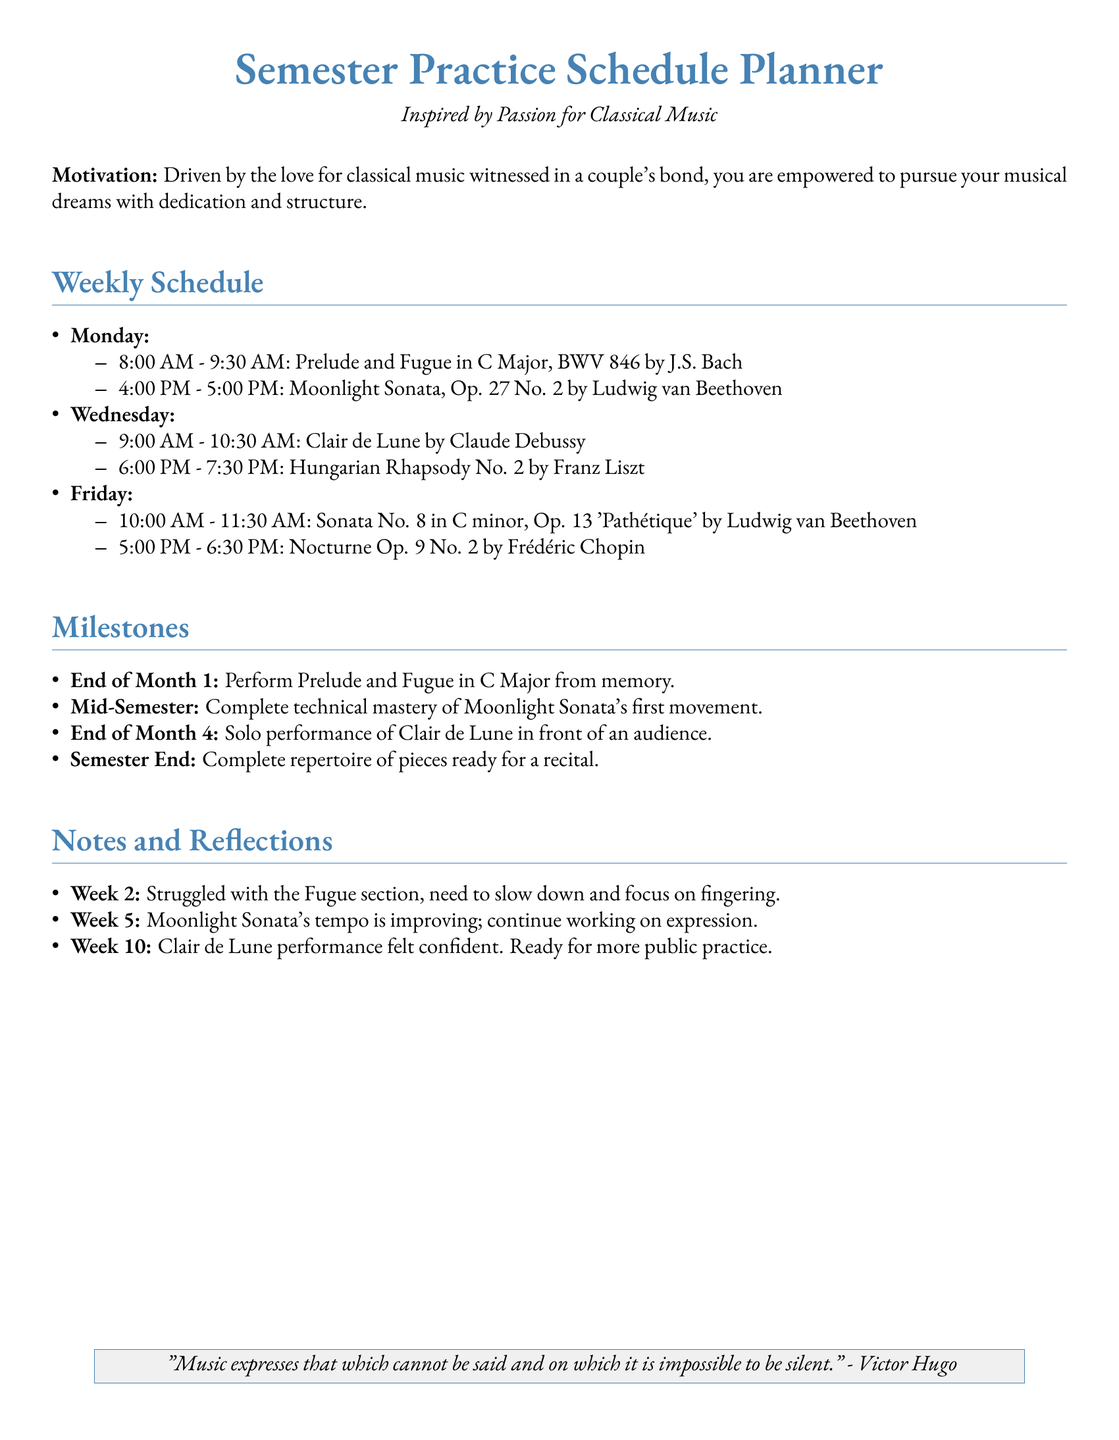what is the title of the document? The title of the document is presented prominently at the beginning, indicating its purpose.
Answer: Semester Practice Schedule Planner who composed the Prelude and Fugue in C Major? This piece is attributed to a well-known composer, highlighted in the schedule.
Answer: J.S. Bach what day is the performance of Clair de Lune scheduled for? The milestone section suggests a specific timeline in the semester for this performance.
Answer: End of Month 4 how many pieces are practiced on Fridays? The schedule lists out the pieces designated for practice on Fridays.
Answer: Two what is the time allocated for practicing the Nocturne Op. 9 No. 2? The schedule specifies the time dedicated to this particular piece on Fridays.
Answer: 5:00 PM - 6:30 PM what is the milestone at the end of Month 1? The milestone section includes specific benchmarks to achieve throughout the semester.
Answer: Perform Prelude and Fugue in C Major from memory which piece has a focus on expression improvement? This specific piece is mentioned in the notes and reflections, indicating an area of focus.
Answer: Moonlight Sonata what is the motivation expressed in the document? The document opens with a motivating statement that describes what inspires the practice schedule.
Answer: Inspired by Passion for Classical Music 